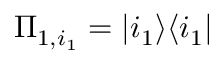Convert formula to latex. <formula><loc_0><loc_0><loc_500><loc_500>\Pi _ { 1 , i _ { 1 } } = | i _ { 1 } \rangle \langle i _ { 1 } |</formula> 